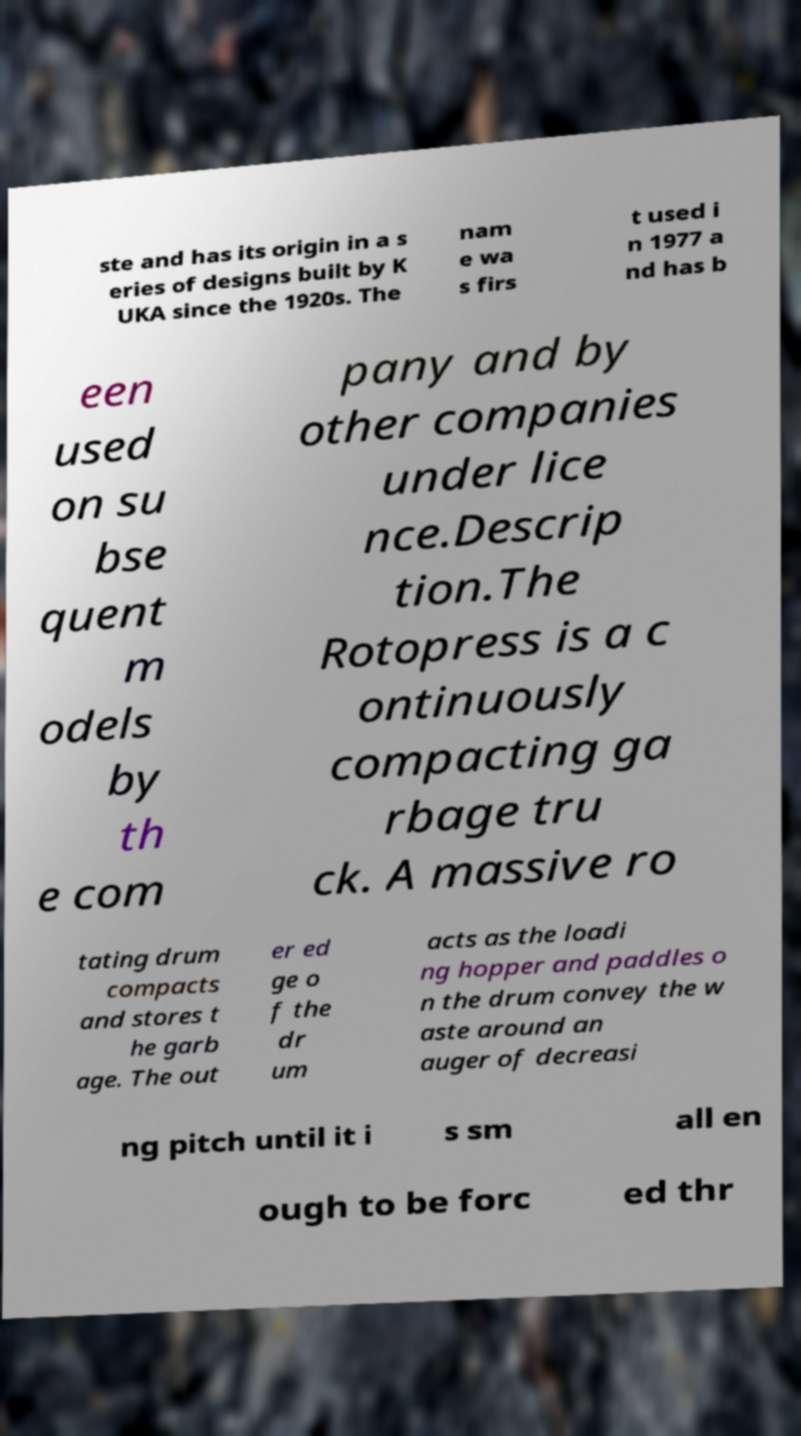There's text embedded in this image that I need extracted. Can you transcribe it verbatim? ste and has its origin in a s eries of designs built by K UKA since the 1920s. The nam e wa s firs t used i n 1977 a nd has b een used on su bse quent m odels by th e com pany and by other companies under lice nce.Descrip tion.The Rotopress is a c ontinuously compacting ga rbage tru ck. A massive ro tating drum compacts and stores t he garb age. The out er ed ge o f the dr um acts as the loadi ng hopper and paddles o n the drum convey the w aste around an auger of decreasi ng pitch until it i s sm all en ough to be forc ed thr 